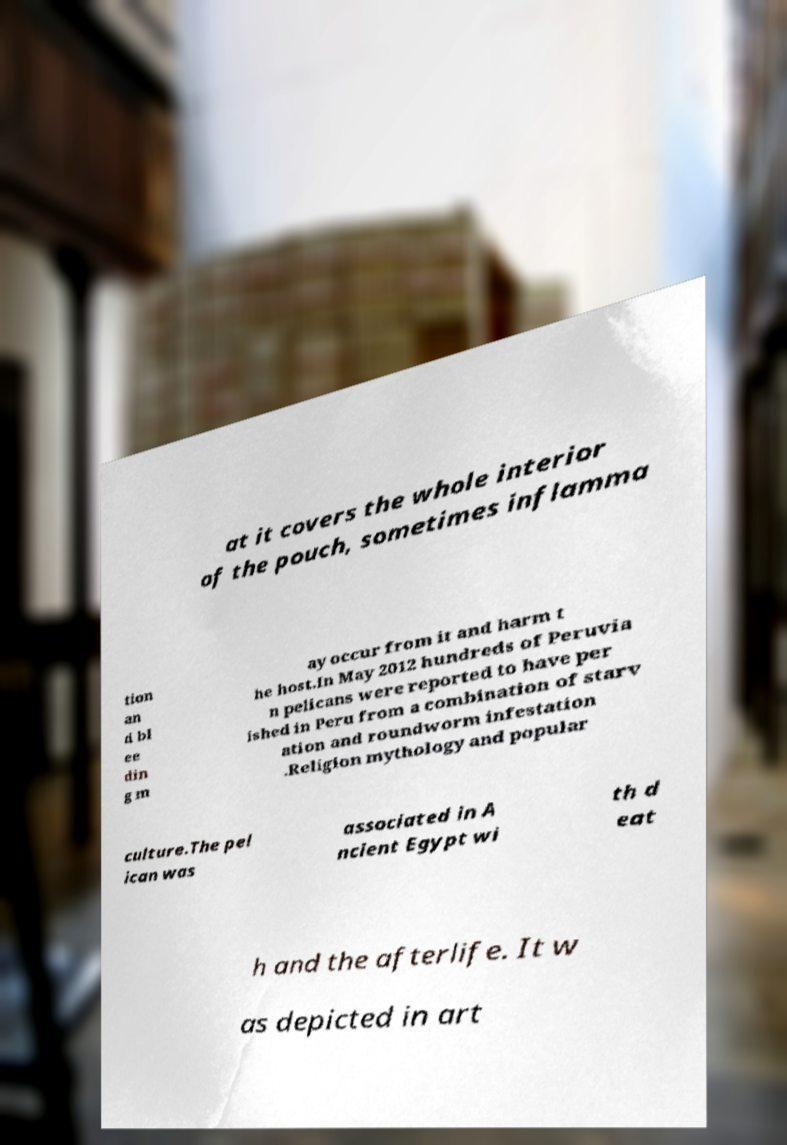Please read and relay the text visible in this image. What does it say? at it covers the whole interior of the pouch, sometimes inflamma tion an d bl ee din g m ay occur from it and harm t he host.In May 2012 hundreds of Peruvia n pelicans were reported to have per ished in Peru from a combination of starv ation and roundworm infestation .Religion mythology and popular culture.The pel ican was associated in A ncient Egypt wi th d eat h and the afterlife. It w as depicted in art 